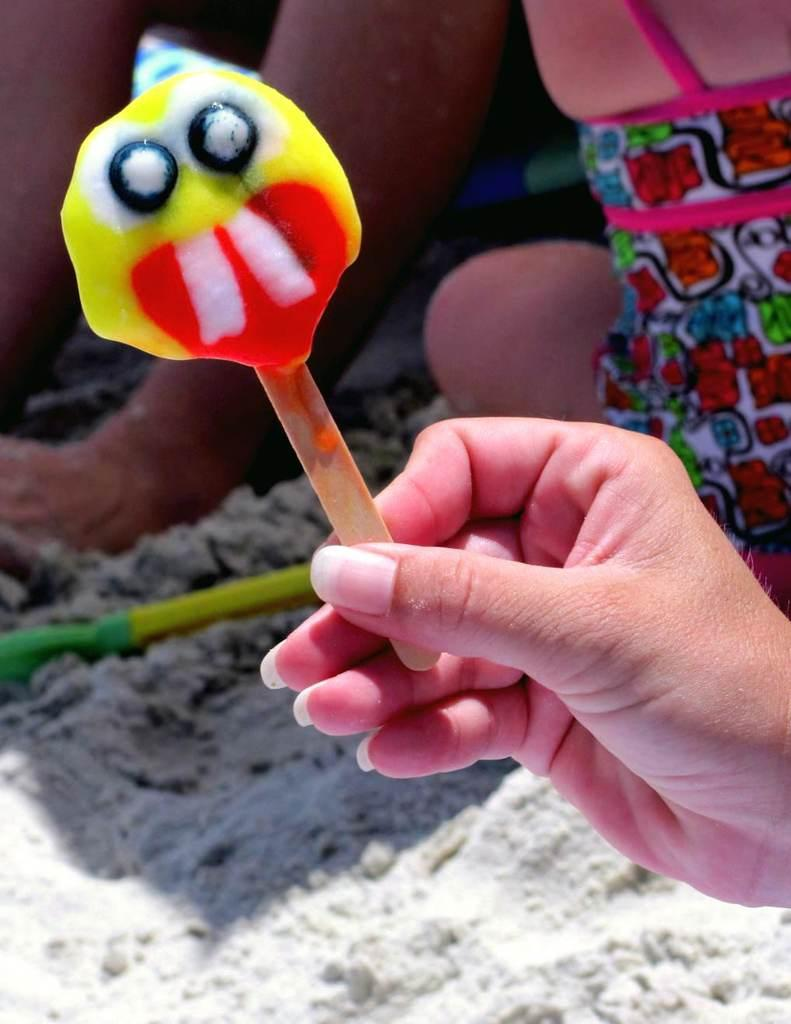What is the person in the image holding? The person is holding an ice cream in the image. Can you describe the surroundings of the person? There are other people in the background of the image. What can be seen beneath the person's feet? The ground is visible in the image. What color is the object that stands out in the image? There is a yellow object in the image. What type of jewel is embedded in the ice cream in the image? There is no jewel embedded in the ice cream in the image. 